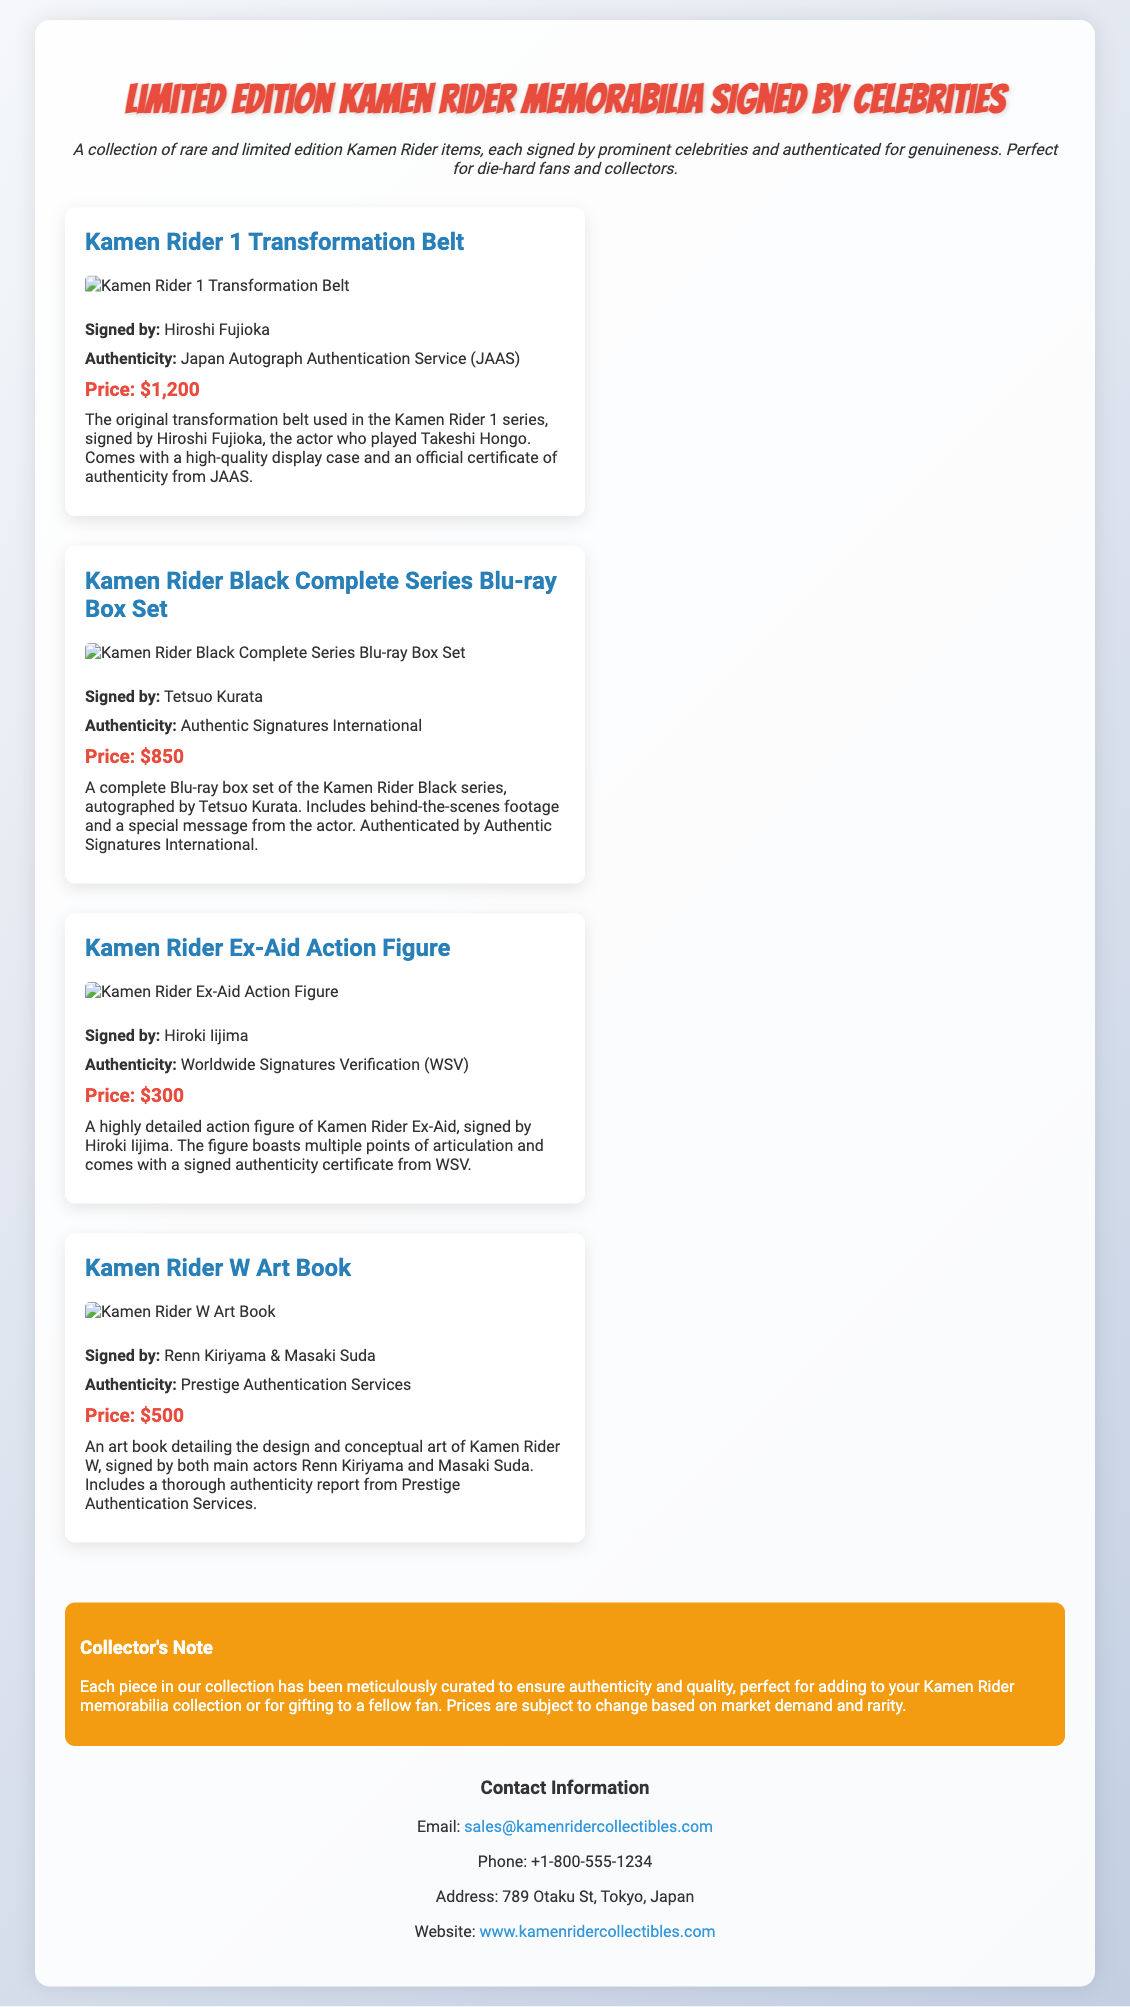What is the title of the product specification sheet? The title is prominently displayed at the top of the document, indicating the type of items featured.
Answer: Limited Edition Kamen Rider Memorabilia Signed by Celebrities Who signed the Kamen Rider 1 Transformation Belt? The document explicitly states who signed each item in the collection.
Answer: Hiroshi Fujioka What is the price of the Kamen Rider Black Complete Series Blu-ray Box Set? The pricing information for each item is clearly listed following the description.
Answer: $850 Which service provided authenticity certification for the Kamen Rider Ex-Aid Action Figure? Each item has an associated authenticity service mentioned in the document.
Answer: Worldwide Signatures Verification (WSV) How many actors signed the Kamen Rider W Art Book? The document specifies the names of the actors who signed the item.
Answer: Two What element is emphasized in the collector's note? The collector's note highlights a key aspect regarding the authenticity and quality of the items.
Answer: Authenticity and quality What type of document is this? This document serves a specific purpose and showcases a unique set of items, characteristic of a particular format.
Answer: Product specification sheet What is the email address provided for contact? The contact information includes an email address that can be found in the contact section of the document.
Answer: sales@kamenridercollectibles.com What visual element accompanies each item description? Each item description includes a visual representation that aids in showcasing the products in the document.
Answer: Image 